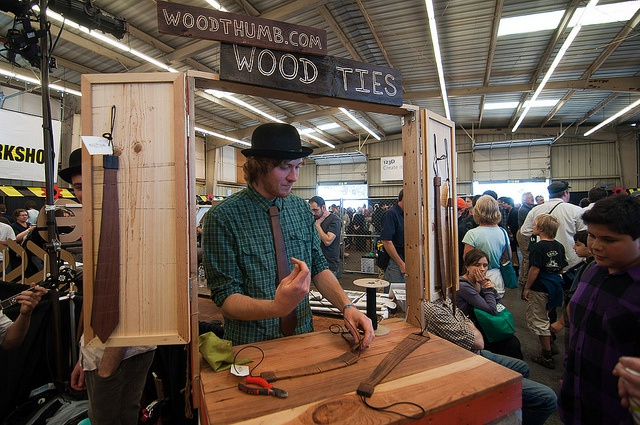Describe the objects in this image and their specific colors. I can see people in black, maroon, and gray tones, people in black, teal, maroon, and gray tones, people in black, maroon, and purple tones, people in black, maroon, and gray tones, and tie in black, maroon, and brown tones in this image. 